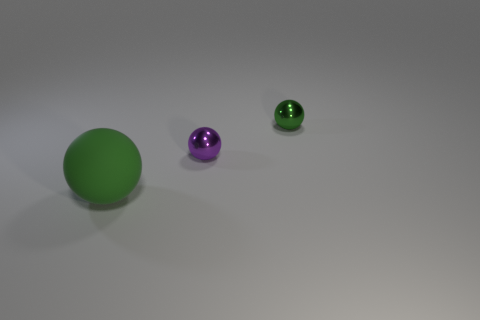Add 3 green metallic spheres. How many objects exist? 6 Add 3 green objects. How many green objects are left? 5 Add 3 tiny green balls. How many tiny green balls exist? 4 Subtract 0 purple cylinders. How many objects are left? 3 Subtract all small purple metal things. Subtract all green metallic objects. How many objects are left? 1 